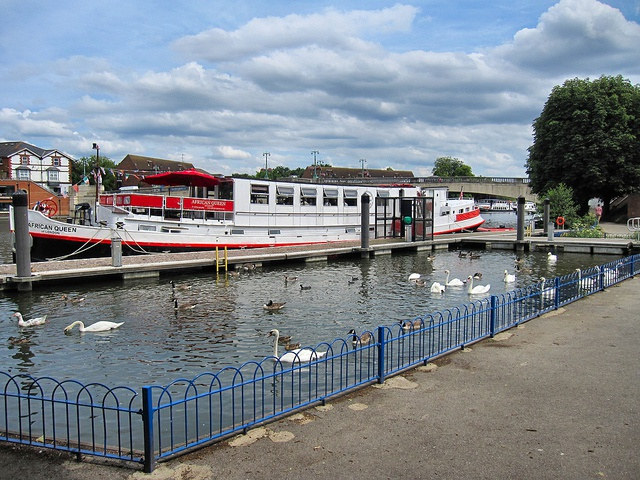Describe the objects in this image and their specific colors. I can see boat in lightblue, lightgray, black, darkgray, and gray tones, bird in lightblue, gray, darkgray, black, and lightgray tones, bird in lightblue, white, darkgray, gray, and black tones, bird in lightblue, lightgray, gray, and darkgray tones, and boat in lightblue, lightgray, darkgray, gray, and black tones in this image. 